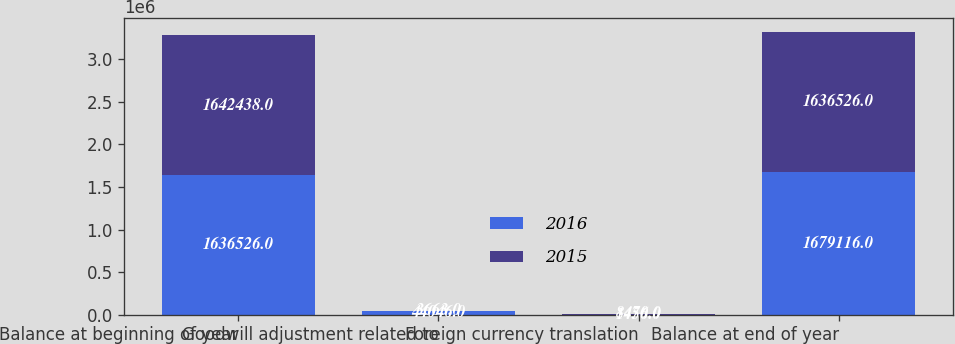<chart> <loc_0><loc_0><loc_500><loc_500><stacked_bar_chart><ecel><fcel>Balance at beginning of year<fcel>Goodwill adjustment related to<fcel>Foreign currency translation<fcel>Balance at end of year<nl><fcel>2016<fcel>1.63653e+06<fcel>44046<fcel>1456<fcel>1.67912e+06<nl><fcel>2015<fcel>1.64244e+06<fcel>3663<fcel>8470<fcel>1.63653e+06<nl></chart> 